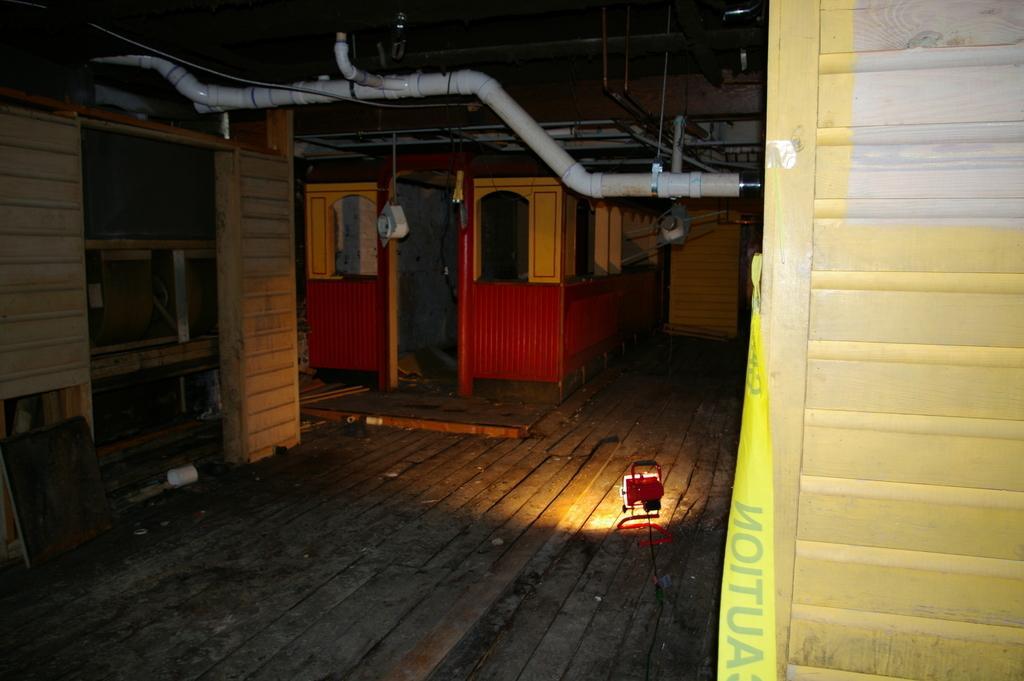Can you describe this image briefly? In this picture we can see a light and some objects on the floor, here we can see wooden objects and some objects. 